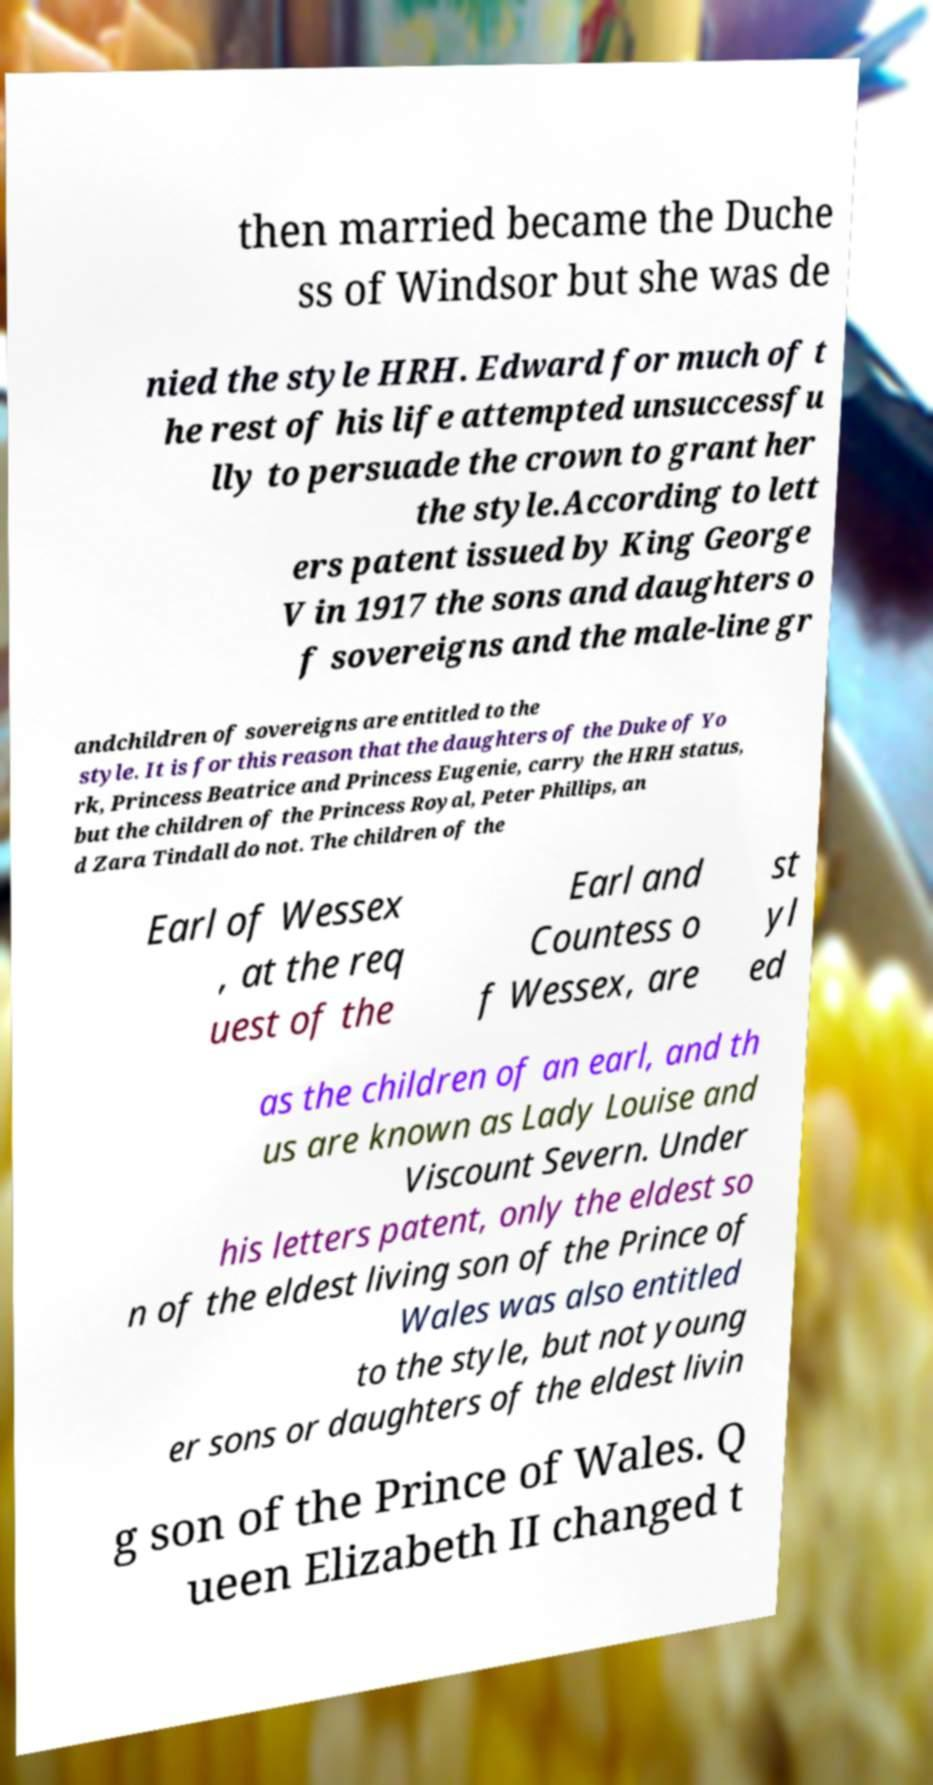What messages or text are displayed in this image? I need them in a readable, typed format. then married became the Duche ss of Windsor but she was de nied the style HRH. Edward for much of t he rest of his life attempted unsuccessfu lly to persuade the crown to grant her the style.According to lett ers patent issued by King George V in 1917 the sons and daughters o f sovereigns and the male-line gr andchildren of sovereigns are entitled to the style. It is for this reason that the daughters of the Duke of Yo rk, Princess Beatrice and Princess Eugenie, carry the HRH status, but the children of the Princess Royal, Peter Phillips, an d Zara Tindall do not. The children of the Earl of Wessex , at the req uest of the Earl and Countess o f Wessex, are st yl ed as the children of an earl, and th us are known as Lady Louise and Viscount Severn. Under his letters patent, only the eldest so n of the eldest living son of the Prince of Wales was also entitled to the style, but not young er sons or daughters of the eldest livin g son of the Prince of Wales. Q ueen Elizabeth II changed t 